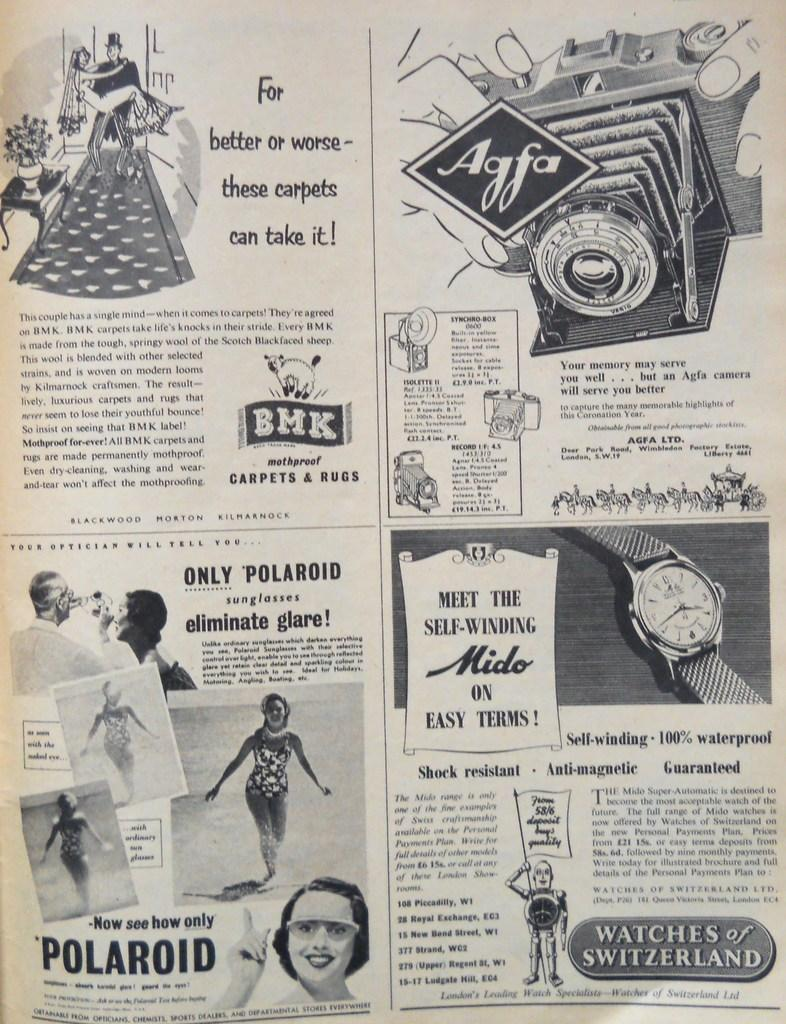<image>
Render a clear and concise summary of the photo. Four advertisements are on a page and of them is about a watch from Switzerland. 